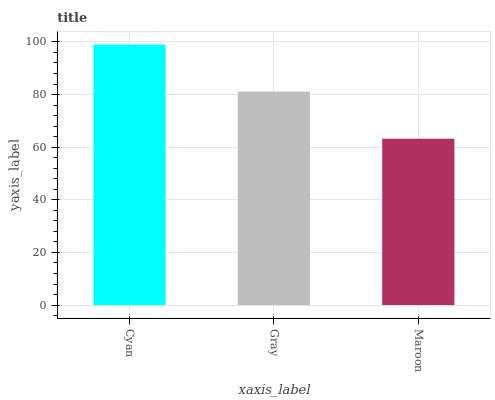Is Maroon the minimum?
Answer yes or no. Yes. Is Cyan the maximum?
Answer yes or no. Yes. Is Gray the minimum?
Answer yes or no. No. Is Gray the maximum?
Answer yes or no. No. Is Cyan greater than Gray?
Answer yes or no. Yes. Is Gray less than Cyan?
Answer yes or no. Yes. Is Gray greater than Cyan?
Answer yes or no. No. Is Cyan less than Gray?
Answer yes or no. No. Is Gray the high median?
Answer yes or no. Yes. Is Gray the low median?
Answer yes or no. Yes. Is Maroon the high median?
Answer yes or no. No. Is Maroon the low median?
Answer yes or no. No. 